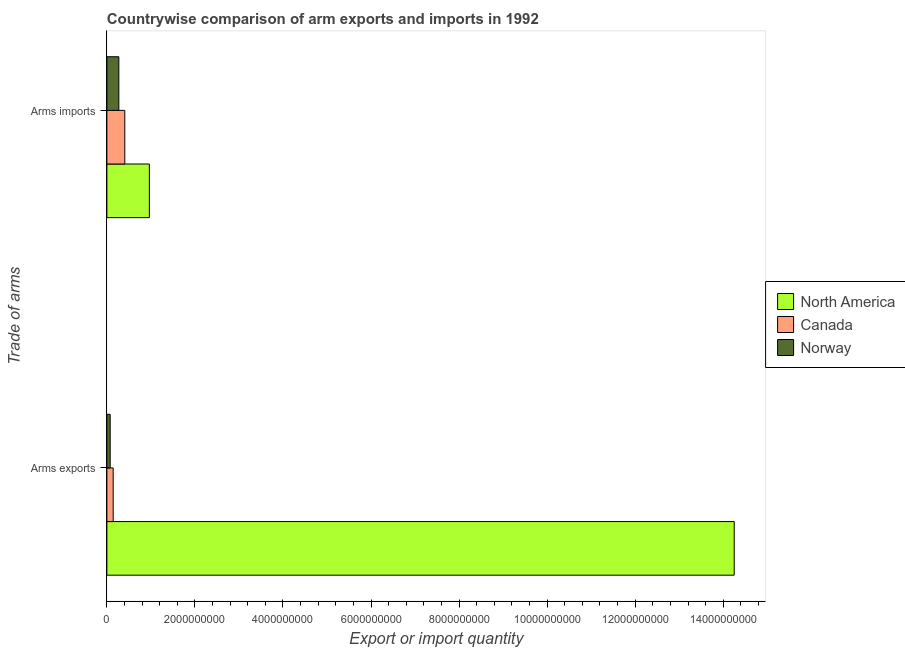Are the number of bars per tick equal to the number of legend labels?
Ensure brevity in your answer.  Yes. Are the number of bars on each tick of the Y-axis equal?
Your response must be concise. Yes. How many bars are there on the 2nd tick from the top?
Offer a very short reply. 3. How many bars are there on the 2nd tick from the bottom?
Offer a very short reply. 3. What is the label of the 1st group of bars from the top?
Ensure brevity in your answer.  Arms imports. What is the arms exports in Canada?
Provide a succinct answer. 1.43e+08. Across all countries, what is the maximum arms imports?
Provide a succinct answer. 9.65e+08. Across all countries, what is the minimum arms exports?
Offer a very short reply. 7.50e+07. What is the total arms exports in the graph?
Your answer should be very brief. 1.45e+1. What is the difference between the arms exports in Norway and that in North America?
Your answer should be compact. -1.42e+1. What is the difference between the arms imports in North America and the arms exports in Norway?
Provide a succinct answer. 8.90e+08. What is the average arms exports per country?
Make the answer very short. 4.82e+09. What is the difference between the arms imports and arms exports in North America?
Provide a succinct answer. -1.33e+1. In how many countries, is the arms imports greater than 13200000000 ?
Give a very brief answer. 0. What is the ratio of the arms imports in North America to that in Norway?
Ensure brevity in your answer.  3.55. Is the arms imports in Canada less than that in Norway?
Your response must be concise. No. Are all the bars in the graph horizontal?
Offer a very short reply. Yes. What is the difference between two consecutive major ticks on the X-axis?
Keep it short and to the point. 2.00e+09. Are the values on the major ticks of X-axis written in scientific E-notation?
Provide a short and direct response. No. Where does the legend appear in the graph?
Make the answer very short. Center right. How are the legend labels stacked?
Your answer should be compact. Vertical. What is the title of the graph?
Your answer should be very brief. Countrywise comparison of arm exports and imports in 1992. Does "Bahrain" appear as one of the legend labels in the graph?
Offer a very short reply. No. What is the label or title of the X-axis?
Make the answer very short. Export or import quantity. What is the label or title of the Y-axis?
Offer a very short reply. Trade of arms. What is the Export or import quantity of North America in Arms exports?
Offer a terse response. 1.42e+1. What is the Export or import quantity of Canada in Arms exports?
Your answer should be compact. 1.43e+08. What is the Export or import quantity in Norway in Arms exports?
Offer a very short reply. 7.50e+07. What is the Export or import quantity of North America in Arms imports?
Give a very brief answer. 9.65e+08. What is the Export or import quantity in Canada in Arms imports?
Your answer should be very brief. 4.07e+08. What is the Export or import quantity in Norway in Arms imports?
Keep it short and to the point. 2.72e+08. Across all Trade of arms, what is the maximum Export or import quantity in North America?
Offer a terse response. 1.42e+1. Across all Trade of arms, what is the maximum Export or import quantity of Canada?
Provide a short and direct response. 4.07e+08. Across all Trade of arms, what is the maximum Export or import quantity in Norway?
Make the answer very short. 2.72e+08. Across all Trade of arms, what is the minimum Export or import quantity of North America?
Give a very brief answer. 9.65e+08. Across all Trade of arms, what is the minimum Export or import quantity in Canada?
Offer a terse response. 1.43e+08. Across all Trade of arms, what is the minimum Export or import quantity in Norway?
Your answer should be very brief. 7.50e+07. What is the total Export or import quantity in North America in the graph?
Offer a very short reply. 1.52e+1. What is the total Export or import quantity of Canada in the graph?
Give a very brief answer. 5.50e+08. What is the total Export or import quantity in Norway in the graph?
Give a very brief answer. 3.47e+08. What is the difference between the Export or import quantity of North America in Arms exports and that in Arms imports?
Ensure brevity in your answer.  1.33e+1. What is the difference between the Export or import quantity of Canada in Arms exports and that in Arms imports?
Your response must be concise. -2.64e+08. What is the difference between the Export or import quantity in Norway in Arms exports and that in Arms imports?
Offer a very short reply. -1.97e+08. What is the difference between the Export or import quantity in North America in Arms exports and the Export or import quantity in Canada in Arms imports?
Give a very brief answer. 1.38e+1. What is the difference between the Export or import quantity in North America in Arms exports and the Export or import quantity in Norway in Arms imports?
Your response must be concise. 1.40e+1. What is the difference between the Export or import quantity in Canada in Arms exports and the Export or import quantity in Norway in Arms imports?
Keep it short and to the point. -1.29e+08. What is the average Export or import quantity in North America per Trade of arms?
Provide a succinct answer. 7.61e+09. What is the average Export or import quantity of Canada per Trade of arms?
Keep it short and to the point. 2.75e+08. What is the average Export or import quantity of Norway per Trade of arms?
Your response must be concise. 1.74e+08. What is the difference between the Export or import quantity in North America and Export or import quantity in Canada in Arms exports?
Your response must be concise. 1.41e+1. What is the difference between the Export or import quantity of North America and Export or import quantity of Norway in Arms exports?
Your answer should be very brief. 1.42e+1. What is the difference between the Export or import quantity in Canada and Export or import quantity in Norway in Arms exports?
Provide a succinct answer. 6.80e+07. What is the difference between the Export or import quantity of North America and Export or import quantity of Canada in Arms imports?
Your answer should be very brief. 5.58e+08. What is the difference between the Export or import quantity of North America and Export or import quantity of Norway in Arms imports?
Make the answer very short. 6.93e+08. What is the difference between the Export or import quantity of Canada and Export or import quantity of Norway in Arms imports?
Offer a very short reply. 1.35e+08. What is the ratio of the Export or import quantity of North America in Arms exports to that in Arms imports?
Give a very brief answer. 14.77. What is the ratio of the Export or import quantity of Canada in Arms exports to that in Arms imports?
Provide a succinct answer. 0.35. What is the ratio of the Export or import quantity in Norway in Arms exports to that in Arms imports?
Give a very brief answer. 0.28. What is the difference between the highest and the second highest Export or import quantity in North America?
Keep it short and to the point. 1.33e+1. What is the difference between the highest and the second highest Export or import quantity of Canada?
Your answer should be compact. 2.64e+08. What is the difference between the highest and the second highest Export or import quantity of Norway?
Your response must be concise. 1.97e+08. What is the difference between the highest and the lowest Export or import quantity in North America?
Your response must be concise. 1.33e+1. What is the difference between the highest and the lowest Export or import quantity of Canada?
Offer a terse response. 2.64e+08. What is the difference between the highest and the lowest Export or import quantity of Norway?
Ensure brevity in your answer.  1.97e+08. 